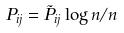<formula> <loc_0><loc_0><loc_500><loc_500>P _ { i j } = \tilde { P } _ { i j } \log n / n</formula> 